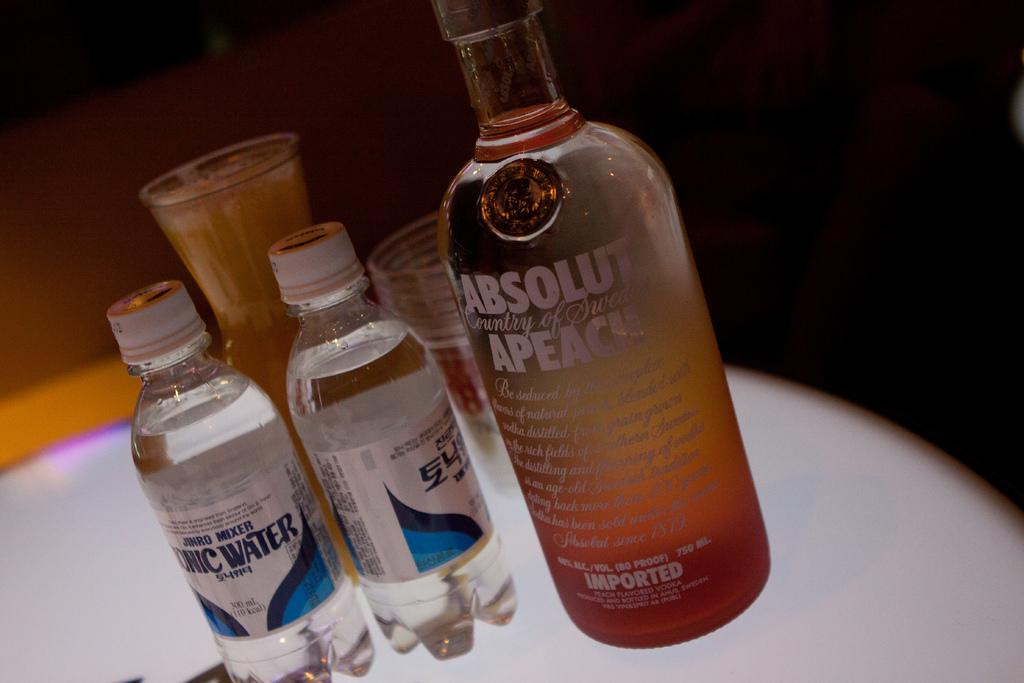<image>
Give a short and clear explanation of the subsequent image. Absolut Peach Alcohol drink with two waters beside it. 